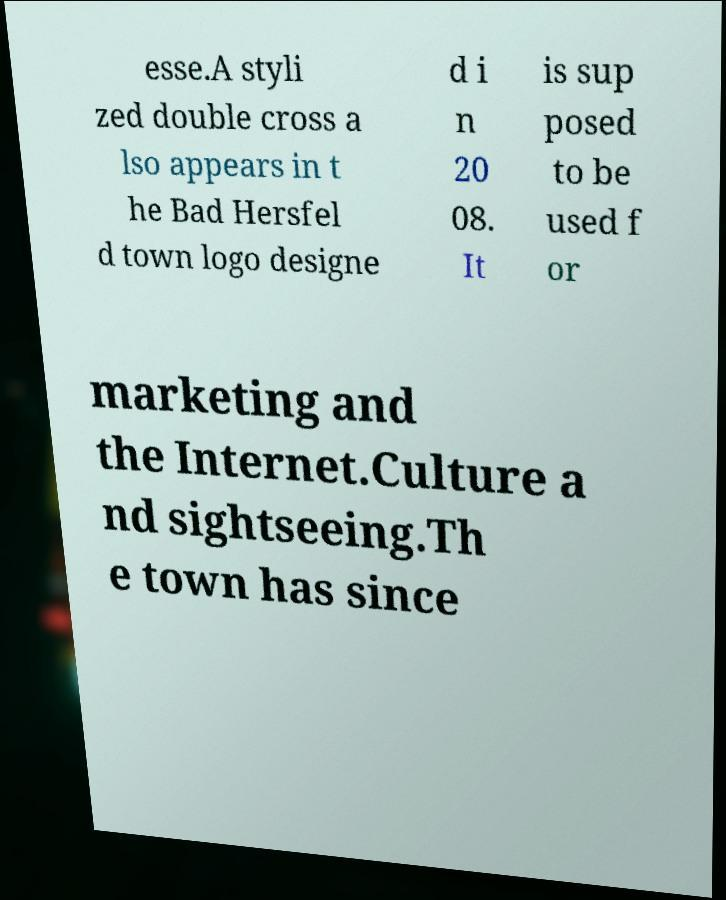Please read and relay the text visible in this image. What does it say? esse.A styli zed double cross a lso appears in t he Bad Hersfel d town logo designe d i n 20 08. It is sup posed to be used f or marketing and the Internet.Culture a nd sightseeing.Th e town has since 